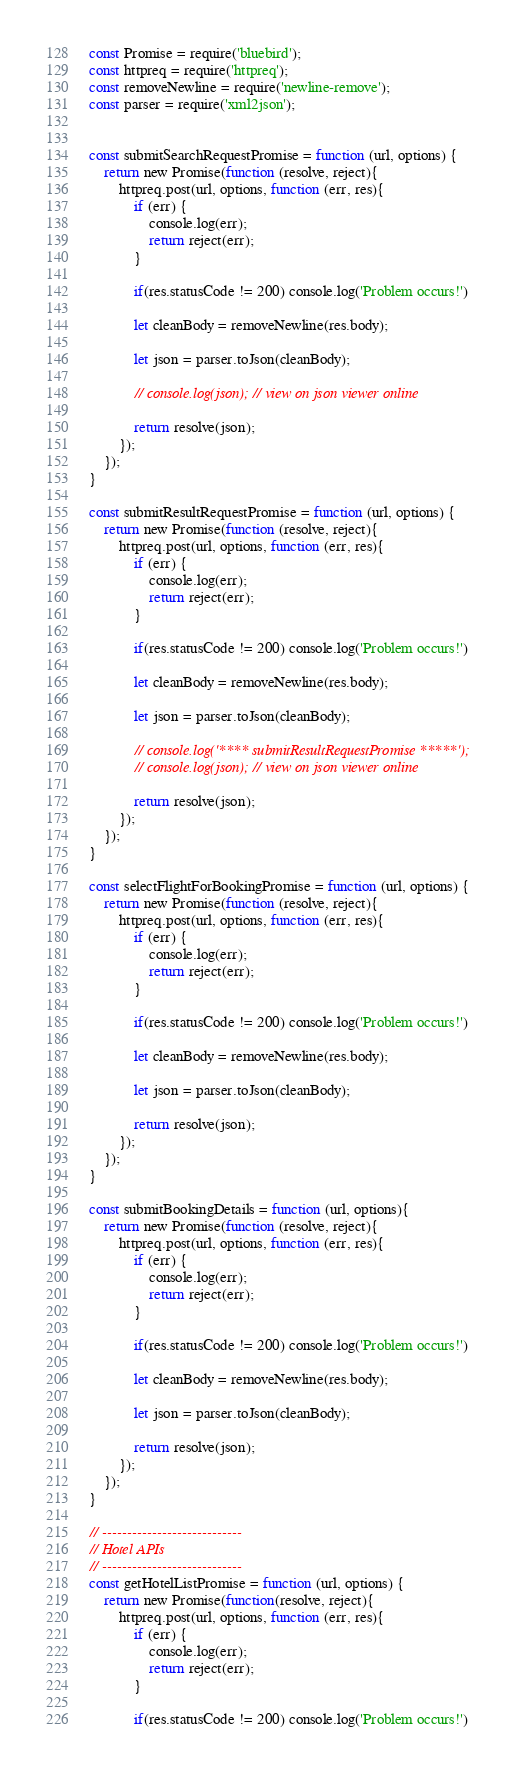Convert code to text. <code><loc_0><loc_0><loc_500><loc_500><_JavaScript_>const Promise = require('bluebird');
const httpreq = require('httpreq');
const removeNewline = require('newline-remove');
const parser = require('xml2json');


const submitSearchRequestPromise = function (url, options) {
    return new Promise(function (resolve, reject){
        httpreq.post(url, options, function (err, res){
            if (err) {
                console.log(err);
                return reject(err);
            }

            if(res.statusCode != 200) console.log('Problem occurs!')

            let cleanBody = removeNewline(res.body);

            let json = parser.toJson(cleanBody);

            // console.log(json); // view on json viewer online

            return resolve(json);
        });
    });
}

const submitResultRequestPromise = function (url, options) {
    return new Promise(function (resolve, reject){
        httpreq.post(url, options, function (err, res){
            if (err) {
                console.log(err);
                return reject(err);
            }

            if(res.statusCode != 200) console.log('Problem occurs!')

            let cleanBody = removeNewline(res.body);

            let json = parser.toJson(cleanBody);

            // console.log('**** submitResultRequestPromise *****');
            // console.log(json); // view on json viewer online

            return resolve(json);
        });
    });
}

const selectFlightForBookingPromise = function (url, options) {
    return new Promise(function (resolve, reject){
        httpreq.post(url, options, function (err, res){
            if (err) {
                console.log(err);
                return reject(err);
            }

            if(res.statusCode != 200) console.log('Problem occurs!')

            let cleanBody = removeNewline(res.body);

            let json = parser.toJson(cleanBody);

            return resolve(json);
        });
    });
}

const submitBookingDetails = function (url, options){
    return new Promise(function (resolve, reject){
        httpreq.post(url, options, function (err, res){
            if (err) {
                console.log(err);
                return reject(err);
            }

            if(res.statusCode != 200) console.log('Problem occurs!')

            let cleanBody = removeNewline(res.body);

            let json = parser.toJson(cleanBody);

            return resolve(json);
        });
    });
}

// ----------------------------
// Hotel APIs
// ----------------------------
const getHotelListPromise = function (url, options) {
    return new Promise(function(resolve, reject){
        httpreq.post(url, options, function (err, res){
            if (err) {
                console.log(err);
                return reject(err);
            }

            if(res.statusCode != 200) console.log('Problem occurs!')
</code> 